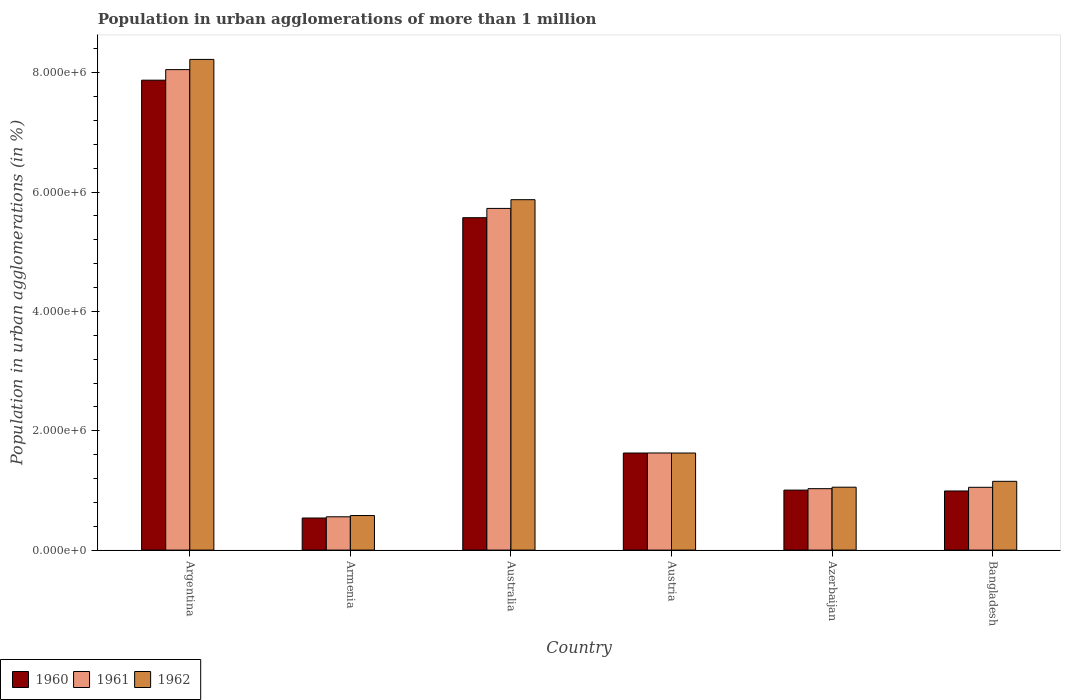How many bars are there on the 2nd tick from the left?
Your response must be concise. 3. In how many cases, is the number of bars for a given country not equal to the number of legend labels?
Make the answer very short. 0. What is the population in urban agglomerations in 1961 in Australia?
Your response must be concise. 5.73e+06. Across all countries, what is the maximum population in urban agglomerations in 1962?
Provide a short and direct response. 8.22e+06. Across all countries, what is the minimum population in urban agglomerations in 1960?
Offer a very short reply. 5.38e+05. In which country was the population in urban agglomerations in 1960 maximum?
Give a very brief answer. Argentina. In which country was the population in urban agglomerations in 1960 minimum?
Ensure brevity in your answer.  Armenia. What is the total population in urban agglomerations in 1962 in the graph?
Your answer should be very brief. 1.85e+07. What is the difference between the population in urban agglomerations in 1960 in Argentina and that in Azerbaijan?
Ensure brevity in your answer.  6.87e+06. What is the difference between the population in urban agglomerations in 1960 in Austria and the population in urban agglomerations in 1962 in Bangladesh?
Offer a very short reply. 4.74e+05. What is the average population in urban agglomerations in 1962 per country?
Keep it short and to the point. 3.08e+06. What is the difference between the population in urban agglomerations of/in 1960 and population in urban agglomerations of/in 1961 in Bangladesh?
Your answer should be very brief. -6.15e+04. In how many countries, is the population in urban agglomerations in 1962 greater than 6000000 %?
Offer a very short reply. 1. What is the ratio of the population in urban agglomerations in 1961 in Argentina to that in Austria?
Your answer should be compact. 4.95. Is the population in urban agglomerations in 1961 in Australia less than that in Austria?
Offer a terse response. No. Is the difference between the population in urban agglomerations in 1960 in Australia and Azerbaijan greater than the difference between the population in urban agglomerations in 1961 in Australia and Azerbaijan?
Keep it short and to the point. No. What is the difference between the highest and the second highest population in urban agglomerations in 1962?
Your response must be concise. -2.35e+06. What is the difference between the highest and the lowest population in urban agglomerations in 1960?
Keep it short and to the point. 7.34e+06. In how many countries, is the population in urban agglomerations in 1962 greater than the average population in urban agglomerations in 1962 taken over all countries?
Keep it short and to the point. 2. What does the 3rd bar from the left in Azerbaijan represents?
Provide a succinct answer. 1962. Is it the case that in every country, the sum of the population in urban agglomerations in 1960 and population in urban agglomerations in 1961 is greater than the population in urban agglomerations in 1962?
Make the answer very short. Yes. How many bars are there?
Offer a very short reply. 18. What is the difference between two consecutive major ticks on the Y-axis?
Ensure brevity in your answer.  2.00e+06. Where does the legend appear in the graph?
Offer a very short reply. Bottom left. How are the legend labels stacked?
Give a very brief answer. Horizontal. What is the title of the graph?
Your answer should be compact. Population in urban agglomerations of more than 1 million. Does "2015" appear as one of the legend labels in the graph?
Make the answer very short. No. What is the label or title of the Y-axis?
Offer a very short reply. Population in urban agglomerations (in %). What is the Population in urban agglomerations (in %) of 1960 in Argentina?
Your response must be concise. 7.87e+06. What is the Population in urban agglomerations (in %) of 1961 in Argentina?
Provide a succinct answer. 8.05e+06. What is the Population in urban agglomerations (in %) in 1962 in Argentina?
Your answer should be very brief. 8.22e+06. What is the Population in urban agglomerations (in %) of 1960 in Armenia?
Give a very brief answer. 5.38e+05. What is the Population in urban agglomerations (in %) in 1961 in Armenia?
Ensure brevity in your answer.  5.58e+05. What is the Population in urban agglomerations (in %) of 1962 in Armenia?
Give a very brief answer. 5.79e+05. What is the Population in urban agglomerations (in %) of 1960 in Australia?
Your answer should be compact. 5.57e+06. What is the Population in urban agglomerations (in %) of 1961 in Australia?
Keep it short and to the point. 5.73e+06. What is the Population in urban agglomerations (in %) of 1962 in Australia?
Provide a succinct answer. 5.87e+06. What is the Population in urban agglomerations (in %) of 1960 in Austria?
Provide a short and direct response. 1.63e+06. What is the Population in urban agglomerations (in %) of 1961 in Austria?
Make the answer very short. 1.63e+06. What is the Population in urban agglomerations (in %) of 1962 in Austria?
Your response must be concise. 1.63e+06. What is the Population in urban agglomerations (in %) of 1960 in Azerbaijan?
Ensure brevity in your answer.  1.01e+06. What is the Population in urban agglomerations (in %) in 1961 in Azerbaijan?
Provide a succinct answer. 1.03e+06. What is the Population in urban agglomerations (in %) of 1962 in Azerbaijan?
Your answer should be compact. 1.05e+06. What is the Population in urban agglomerations (in %) in 1960 in Bangladesh?
Offer a terse response. 9.91e+05. What is the Population in urban agglomerations (in %) of 1961 in Bangladesh?
Give a very brief answer. 1.05e+06. What is the Population in urban agglomerations (in %) of 1962 in Bangladesh?
Your answer should be compact. 1.15e+06. Across all countries, what is the maximum Population in urban agglomerations (in %) in 1960?
Provide a succinct answer. 7.87e+06. Across all countries, what is the maximum Population in urban agglomerations (in %) in 1961?
Provide a short and direct response. 8.05e+06. Across all countries, what is the maximum Population in urban agglomerations (in %) of 1962?
Provide a succinct answer. 8.22e+06. Across all countries, what is the minimum Population in urban agglomerations (in %) of 1960?
Provide a succinct answer. 5.38e+05. Across all countries, what is the minimum Population in urban agglomerations (in %) in 1961?
Your response must be concise. 5.58e+05. Across all countries, what is the minimum Population in urban agglomerations (in %) in 1962?
Provide a short and direct response. 5.79e+05. What is the total Population in urban agglomerations (in %) of 1960 in the graph?
Give a very brief answer. 1.76e+07. What is the total Population in urban agglomerations (in %) of 1961 in the graph?
Your answer should be very brief. 1.80e+07. What is the total Population in urban agglomerations (in %) of 1962 in the graph?
Your answer should be very brief. 1.85e+07. What is the difference between the Population in urban agglomerations (in %) in 1960 in Argentina and that in Armenia?
Provide a succinct answer. 7.34e+06. What is the difference between the Population in urban agglomerations (in %) in 1961 in Argentina and that in Armenia?
Provide a short and direct response. 7.49e+06. What is the difference between the Population in urban agglomerations (in %) in 1962 in Argentina and that in Armenia?
Provide a succinct answer. 7.64e+06. What is the difference between the Population in urban agglomerations (in %) in 1960 in Argentina and that in Australia?
Your answer should be compact. 2.30e+06. What is the difference between the Population in urban agglomerations (in %) of 1961 in Argentina and that in Australia?
Your response must be concise. 2.33e+06. What is the difference between the Population in urban agglomerations (in %) of 1962 in Argentina and that in Australia?
Your answer should be very brief. 2.35e+06. What is the difference between the Population in urban agglomerations (in %) of 1960 in Argentina and that in Austria?
Provide a short and direct response. 6.25e+06. What is the difference between the Population in urban agglomerations (in %) of 1961 in Argentina and that in Austria?
Keep it short and to the point. 6.42e+06. What is the difference between the Population in urban agglomerations (in %) of 1962 in Argentina and that in Austria?
Offer a very short reply. 6.60e+06. What is the difference between the Population in urban agglomerations (in %) of 1960 in Argentina and that in Azerbaijan?
Your answer should be compact. 6.87e+06. What is the difference between the Population in urban agglomerations (in %) in 1961 in Argentina and that in Azerbaijan?
Offer a very short reply. 7.02e+06. What is the difference between the Population in urban agglomerations (in %) of 1962 in Argentina and that in Azerbaijan?
Provide a succinct answer. 7.17e+06. What is the difference between the Population in urban agglomerations (in %) of 1960 in Argentina and that in Bangladesh?
Your answer should be very brief. 6.88e+06. What is the difference between the Population in urban agglomerations (in %) in 1961 in Argentina and that in Bangladesh?
Your response must be concise. 7.00e+06. What is the difference between the Population in urban agglomerations (in %) of 1962 in Argentina and that in Bangladesh?
Give a very brief answer. 7.07e+06. What is the difference between the Population in urban agglomerations (in %) of 1960 in Armenia and that in Australia?
Ensure brevity in your answer.  -5.03e+06. What is the difference between the Population in urban agglomerations (in %) in 1961 in Armenia and that in Australia?
Your answer should be very brief. -5.17e+06. What is the difference between the Population in urban agglomerations (in %) in 1962 in Armenia and that in Australia?
Keep it short and to the point. -5.29e+06. What is the difference between the Population in urban agglomerations (in %) in 1960 in Armenia and that in Austria?
Your response must be concise. -1.09e+06. What is the difference between the Population in urban agglomerations (in %) in 1961 in Armenia and that in Austria?
Keep it short and to the point. -1.07e+06. What is the difference between the Population in urban agglomerations (in %) in 1962 in Armenia and that in Austria?
Offer a terse response. -1.05e+06. What is the difference between the Population in urban agglomerations (in %) in 1960 in Armenia and that in Azerbaijan?
Offer a very short reply. -4.68e+05. What is the difference between the Population in urban agglomerations (in %) of 1961 in Armenia and that in Azerbaijan?
Ensure brevity in your answer.  -4.71e+05. What is the difference between the Population in urban agglomerations (in %) of 1962 in Armenia and that in Azerbaijan?
Provide a short and direct response. -4.75e+05. What is the difference between the Population in urban agglomerations (in %) in 1960 in Armenia and that in Bangladesh?
Provide a succinct answer. -4.53e+05. What is the difference between the Population in urban agglomerations (in %) in 1961 in Armenia and that in Bangladesh?
Offer a very short reply. -4.94e+05. What is the difference between the Population in urban agglomerations (in %) in 1962 in Armenia and that in Bangladesh?
Offer a very short reply. -5.73e+05. What is the difference between the Population in urban agglomerations (in %) of 1960 in Australia and that in Austria?
Offer a terse response. 3.94e+06. What is the difference between the Population in urban agglomerations (in %) of 1961 in Australia and that in Austria?
Offer a very short reply. 4.10e+06. What is the difference between the Population in urban agglomerations (in %) of 1962 in Australia and that in Austria?
Your answer should be very brief. 4.25e+06. What is the difference between the Population in urban agglomerations (in %) in 1960 in Australia and that in Azerbaijan?
Give a very brief answer. 4.56e+06. What is the difference between the Population in urban agglomerations (in %) of 1961 in Australia and that in Azerbaijan?
Make the answer very short. 4.70e+06. What is the difference between the Population in urban agglomerations (in %) in 1962 in Australia and that in Azerbaijan?
Give a very brief answer. 4.82e+06. What is the difference between the Population in urban agglomerations (in %) in 1960 in Australia and that in Bangladesh?
Your answer should be compact. 4.58e+06. What is the difference between the Population in urban agglomerations (in %) of 1961 in Australia and that in Bangladesh?
Make the answer very short. 4.67e+06. What is the difference between the Population in urban agglomerations (in %) of 1962 in Australia and that in Bangladesh?
Offer a very short reply. 4.72e+06. What is the difference between the Population in urban agglomerations (in %) in 1960 in Austria and that in Azerbaijan?
Make the answer very short. 6.21e+05. What is the difference between the Population in urban agglomerations (in %) in 1961 in Austria and that in Azerbaijan?
Offer a terse response. 5.98e+05. What is the difference between the Population in urban agglomerations (in %) of 1962 in Austria and that in Azerbaijan?
Offer a very short reply. 5.72e+05. What is the difference between the Population in urban agglomerations (in %) of 1960 in Austria and that in Bangladesh?
Keep it short and to the point. 6.36e+05. What is the difference between the Population in urban agglomerations (in %) of 1961 in Austria and that in Bangladesh?
Keep it short and to the point. 5.75e+05. What is the difference between the Population in urban agglomerations (in %) in 1962 in Austria and that in Bangladesh?
Make the answer very short. 4.74e+05. What is the difference between the Population in urban agglomerations (in %) of 1960 in Azerbaijan and that in Bangladesh?
Offer a terse response. 1.46e+04. What is the difference between the Population in urban agglomerations (in %) in 1961 in Azerbaijan and that in Bangladesh?
Provide a succinct answer. -2.27e+04. What is the difference between the Population in urban agglomerations (in %) of 1962 in Azerbaijan and that in Bangladesh?
Your answer should be very brief. -9.84e+04. What is the difference between the Population in urban agglomerations (in %) in 1960 in Argentina and the Population in urban agglomerations (in %) in 1961 in Armenia?
Provide a succinct answer. 7.32e+06. What is the difference between the Population in urban agglomerations (in %) in 1960 in Argentina and the Population in urban agglomerations (in %) in 1962 in Armenia?
Offer a very short reply. 7.30e+06. What is the difference between the Population in urban agglomerations (in %) in 1961 in Argentina and the Population in urban agglomerations (in %) in 1962 in Armenia?
Make the answer very short. 7.47e+06. What is the difference between the Population in urban agglomerations (in %) in 1960 in Argentina and the Population in urban agglomerations (in %) in 1961 in Australia?
Offer a terse response. 2.15e+06. What is the difference between the Population in urban agglomerations (in %) of 1960 in Argentina and the Population in urban agglomerations (in %) of 1962 in Australia?
Your answer should be compact. 2.00e+06. What is the difference between the Population in urban agglomerations (in %) of 1961 in Argentina and the Population in urban agglomerations (in %) of 1962 in Australia?
Your answer should be very brief. 2.18e+06. What is the difference between the Population in urban agglomerations (in %) in 1960 in Argentina and the Population in urban agglomerations (in %) in 1961 in Austria?
Make the answer very short. 6.25e+06. What is the difference between the Population in urban agglomerations (in %) of 1960 in Argentina and the Population in urban agglomerations (in %) of 1962 in Austria?
Your answer should be very brief. 6.25e+06. What is the difference between the Population in urban agglomerations (in %) of 1961 in Argentina and the Population in urban agglomerations (in %) of 1962 in Austria?
Give a very brief answer. 6.42e+06. What is the difference between the Population in urban agglomerations (in %) in 1960 in Argentina and the Population in urban agglomerations (in %) in 1961 in Azerbaijan?
Provide a short and direct response. 6.84e+06. What is the difference between the Population in urban agglomerations (in %) in 1960 in Argentina and the Population in urban agglomerations (in %) in 1962 in Azerbaijan?
Provide a short and direct response. 6.82e+06. What is the difference between the Population in urban agglomerations (in %) of 1961 in Argentina and the Population in urban agglomerations (in %) of 1962 in Azerbaijan?
Your answer should be compact. 7.00e+06. What is the difference between the Population in urban agglomerations (in %) of 1960 in Argentina and the Population in urban agglomerations (in %) of 1961 in Bangladesh?
Keep it short and to the point. 6.82e+06. What is the difference between the Population in urban agglomerations (in %) of 1960 in Argentina and the Population in urban agglomerations (in %) of 1962 in Bangladesh?
Give a very brief answer. 6.72e+06. What is the difference between the Population in urban agglomerations (in %) of 1961 in Argentina and the Population in urban agglomerations (in %) of 1962 in Bangladesh?
Provide a succinct answer. 6.90e+06. What is the difference between the Population in urban agglomerations (in %) in 1960 in Armenia and the Population in urban agglomerations (in %) in 1961 in Australia?
Ensure brevity in your answer.  -5.19e+06. What is the difference between the Population in urban agglomerations (in %) in 1960 in Armenia and the Population in urban agglomerations (in %) in 1962 in Australia?
Offer a terse response. -5.33e+06. What is the difference between the Population in urban agglomerations (in %) in 1961 in Armenia and the Population in urban agglomerations (in %) in 1962 in Australia?
Keep it short and to the point. -5.31e+06. What is the difference between the Population in urban agglomerations (in %) in 1960 in Armenia and the Population in urban agglomerations (in %) in 1961 in Austria?
Your answer should be very brief. -1.09e+06. What is the difference between the Population in urban agglomerations (in %) of 1960 in Armenia and the Population in urban agglomerations (in %) of 1962 in Austria?
Offer a very short reply. -1.09e+06. What is the difference between the Population in urban agglomerations (in %) of 1961 in Armenia and the Population in urban agglomerations (in %) of 1962 in Austria?
Offer a terse response. -1.07e+06. What is the difference between the Population in urban agglomerations (in %) of 1960 in Armenia and the Population in urban agglomerations (in %) of 1961 in Azerbaijan?
Provide a succinct answer. -4.92e+05. What is the difference between the Population in urban agglomerations (in %) in 1960 in Armenia and the Population in urban agglomerations (in %) in 1962 in Azerbaijan?
Your answer should be very brief. -5.16e+05. What is the difference between the Population in urban agglomerations (in %) in 1961 in Armenia and the Population in urban agglomerations (in %) in 1962 in Azerbaijan?
Provide a short and direct response. -4.96e+05. What is the difference between the Population in urban agglomerations (in %) in 1960 in Armenia and the Population in urban agglomerations (in %) in 1961 in Bangladesh?
Your response must be concise. -5.14e+05. What is the difference between the Population in urban agglomerations (in %) of 1960 in Armenia and the Population in urban agglomerations (in %) of 1962 in Bangladesh?
Provide a short and direct response. -6.15e+05. What is the difference between the Population in urban agglomerations (in %) of 1961 in Armenia and the Population in urban agglomerations (in %) of 1962 in Bangladesh?
Ensure brevity in your answer.  -5.94e+05. What is the difference between the Population in urban agglomerations (in %) of 1960 in Australia and the Population in urban agglomerations (in %) of 1961 in Austria?
Give a very brief answer. 3.94e+06. What is the difference between the Population in urban agglomerations (in %) in 1960 in Australia and the Population in urban agglomerations (in %) in 1962 in Austria?
Provide a succinct answer. 3.94e+06. What is the difference between the Population in urban agglomerations (in %) of 1961 in Australia and the Population in urban agglomerations (in %) of 1962 in Austria?
Give a very brief answer. 4.10e+06. What is the difference between the Population in urban agglomerations (in %) of 1960 in Australia and the Population in urban agglomerations (in %) of 1961 in Azerbaijan?
Provide a short and direct response. 4.54e+06. What is the difference between the Population in urban agglomerations (in %) of 1960 in Australia and the Population in urban agglomerations (in %) of 1962 in Azerbaijan?
Provide a short and direct response. 4.52e+06. What is the difference between the Population in urban agglomerations (in %) in 1961 in Australia and the Population in urban agglomerations (in %) in 1962 in Azerbaijan?
Offer a terse response. 4.67e+06. What is the difference between the Population in urban agglomerations (in %) in 1960 in Australia and the Population in urban agglomerations (in %) in 1961 in Bangladesh?
Give a very brief answer. 4.52e+06. What is the difference between the Population in urban agglomerations (in %) in 1960 in Australia and the Population in urban agglomerations (in %) in 1962 in Bangladesh?
Offer a very short reply. 4.42e+06. What is the difference between the Population in urban agglomerations (in %) of 1961 in Australia and the Population in urban agglomerations (in %) of 1962 in Bangladesh?
Your answer should be compact. 4.57e+06. What is the difference between the Population in urban agglomerations (in %) in 1960 in Austria and the Population in urban agglomerations (in %) in 1961 in Azerbaijan?
Provide a short and direct response. 5.97e+05. What is the difference between the Population in urban agglomerations (in %) of 1960 in Austria and the Population in urban agglomerations (in %) of 1962 in Azerbaijan?
Provide a short and direct response. 5.73e+05. What is the difference between the Population in urban agglomerations (in %) of 1961 in Austria and the Population in urban agglomerations (in %) of 1962 in Azerbaijan?
Provide a short and direct response. 5.73e+05. What is the difference between the Population in urban agglomerations (in %) of 1960 in Austria and the Population in urban agglomerations (in %) of 1961 in Bangladesh?
Your answer should be compact. 5.75e+05. What is the difference between the Population in urban agglomerations (in %) in 1960 in Austria and the Population in urban agglomerations (in %) in 1962 in Bangladesh?
Provide a succinct answer. 4.74e+05. What is the difference between the Population in urban agglomerations (in %) in 1961 in Austria and the Population in urban agglomerations (in %) in 1962 in Bangladesh?
Offer a terse response. 4.75e+05. What is the difference between the Population in urban agglomerations (in %) of 1960 in Azerbaijan and the Population in urban agglomerations (in %) of 1961 in Bangladesh?
Your response must be concise. -4.69e+04. What is the difference between the Population in urban agglomerations (in %) in 1960 in Azerbaijan and the Population in urban agglomerations (in %) in 1962 in Bangladesh?
Your answer should be compact. -1.47e+05. What is the difference between the Population in urban agglomerations (in %) in 1961 in Azerbaijan and the Population in urban agglomerations (in %) in 1962 in Bangladesh?
Your answer should be very brief. -1.23e+05. What is the average Population in urban agglomerations (in %) of 1960 per country?
Your response must be concise. 2.93e+06. What is the average Population in urban agglomerations (in %) in 1961 per country?
Make the answer very short. 3.01e+06. What is the average Population in urban agglomerations (in %) in 1962 per country?
Offer a terse response. 3.08e+06. What is the difference between the Population in urban agglomerations (in %) in 1960 and Population in urban agglomerations (in %) in 1961 in Argentina?
Ensure brevity in your answer.  -1.77e+05. What is the difference between the Population in urban agglomerations (in %) of 1960 and Population in urban agglomerations (in %) of 1962 in Argentina?
Ensure brevity in your answer.  -3.48e+05. What is the difference between the Population in urban agglomerations (in %) of 1961 and Population in urban agglomerations (in %) of 1962 in Argentina?
Your answer should be very brief. -1.71e+05. What is the difference between the Population in urban agglomerations (in %) of 1960 and Population in urban agglomerations (in %) of 1961 in Armenia?
Provide a succinct answer. -2.04e+04. What is the difference between the Population in urban agglomerations (in %) of 1960 and Population in urban agglomerations (in %) of 1962 in Armenia?
Provide a succinct answer. -4.15e+04. What is the difference between the Population in urban agglomerations (in %) of 1961 and Population in urban agglomerations (in %) of 1962 in Armenia?
Provide a succinct answer. -2.12e+04. What is the difference between the Population in urban agglomerations (in %) of 1960 and Population in urban agglomerations (in %) of 1961 in Australia?
Offer a terse response. -1.55e+05. What is the difference between the Population in urban agglomerations (in %) of 1960 and Population in urban agglomerations (in %) of 1962 in Australia?
Provide a short and direct response. -3.02e+05. What is the difference between the Population in urban agglomerations (in %) of 1961 and Population in urban agglomerations (in %) of 1962 in Australia?
Your answer should be compact. -1.46e+05. What is the difference between the Population in urban agglomerations (in %) of 1960 and Population in urban agglomerations (in %) of 1961 in Austria?
Your answer should be compact. -630. What is the difference between the Population in urban agglomerations (in %) of 1960 and Population in urban agglomerations (in %) of 1962 in Austria?
Your response must be concise. 129. What is the difference between the Population in urban agglomerations (in %) of 1961 and Population in urban agglomerations (in %) of 1962 in Austria?
Ensure brevity in your answer.  759. What is the difference between the Population in urban agglomerations (in %) in 1960 and Population in urban agglomerations (in %) in 1961 in Azerbaijan?
Keep it short and to the point. -2.41e+04. What is the difference between the Population in urban agglomerations (in %) in 1960 and Population in urban agglomerations (in %) in 1962 in Azerbaijan?
Your answer should be compact. -4.89e+04. What is the difference between the Population in urban agglomerations (in %) in 1961 and Population in urban agglomerations (in %) in 1962 in Azerbaijan?
Offer a terse response. -2.47e+04. What is the difference between the Population in urban agglomerations (in %) of 1960 and Population in urban agglomerations (in %) of 1961 in Bangladesh?
Your answer should be compact. -6.15e+04. What is the difference between the Population in urban agglomerations (in %) in 1960 and Population in urban agglomerations (in %) in 1962 in Bangladesh?
Make the answer very short. -1.62e+05. What is the difference between the Population in urban agglomerations (in %) of 1961 and Population in urban agglomerations (in %) of 1962 in Bangladesh?
Provide a short and direct response. -1.00e+05. What is the ratio of the Population in urban agglomerations (in %) of 1960 in Argentina to that in Armenia?
Give a very brief answer. 14.64. What is the ratio of the Population in urban agglomerations (in %) in 1961 in Argentina to that in Armenia?
Keep it short and to the point. 14.43. What is the ratio of the Population in urban agglomerations (in %) of 1962 in Argentina to that in Armenia?
Provide a short and direct response. 14.19. What is the ratio of the Population in urban agglomerations (in %) in 1960 in Argentina to that in Australia?
Your response must be concise. 1.41. What is the ratio of the Population in urban agglomerations (in %) in 1961 in Argentina to that in Australia?
Your response must be concise. 1.41. What is the ratio of the Population in urban agglomerations (in %) in 1962 in Argentina to that in Australia?
Provide a succinct answer. 1.4. What is the ratio of the Population in urban agglomerations (in %) of 1960 in Argentina to that in Austria?
Make the answer very short. 4.84. What is the ratio of the Population in urban agglomerations (in %) in 1961 in Argentina to that in Austria?
Provide a short and direct response. 4.95. What is the ratio of the Population in urban agglomerations (in %) of 1962 in Argentina to that in Austria?
Provide a short and direct response. 5.05. What is the ratio of the Population in urban agglomerations (in %) of 1960 in Argentina to that in Azerbaijan?
Your answer should be compact. 7.83. What is the ratio of the Population in urban agglomerations (in %) of 1961 in Argentina to that in Azerbaijan?
Your answer should be compact. 7.82. What is the ratio of the Population in urban agglomerations (in %) of 1962 in Argentina to that in Azerbaijan?
Provide a short and direct response. 7.8. What is the ratio of the Population in urban agglomerations (in %) in 1960 in Argentina to that in Bangladesh?
Offer a very short reply. 7.95. What is the ratio of the Population in urban agglomerations (in %) in 1961 in Argentina to that in Bangladesh?
Your response must be concise. 7.65. What is the ratio of the Population in urban agglomerations (in %) in 1962 in Argentina to that in Bangladesh?
Keep it short and to the point. 7.13. What is the ratio of the Population in urban agglomerations (in %) in 1960 in Armenia to that in Australia?
Keep it short and to the point. 0.1. What is the ratio of the Population in urban agglomerations (in %) of 1961 in Armenia to that in Australia?
Your answer should be compact. 0.1. What is the ratio of the Population in urban agglomerations (in %) in 1962 in Armenia to that in Australia?
Provide a short and direct response. 0.1. What is the ratio of the Population in urban agglomerations (in %) in 1960 in Armenia to that in Austria?
Make the answer very short. 0.33. What is the ratio of the Population in urban agglomerations (in %) of 1961 in Armenia to that in Austria?
Keep it short and to the point. 0.34. What is the ratio of the Population in urban agglomerations (in %) of 1962 in Armenia to that in Austria?
Give a very brief answer. 0.36. What is the ratio of the Population in urban agglomerations (in %) in 1960 in Armenia to that in Azerbaijan?
Make the answer very short. 0.53. What is the ratio of the Population in urban agglomerations (in %) in 1961 in Armenia to that in Azerbaijan?
Provide a short and direct response. 0.54. What is the ratio of the Population in urban agglomerations (in %) in 1962 in Armenia to that in Azerbaijan?
Keep it short and to the point. 0.55. What is the ratio of the Population in urban agglomerations (in %) of 1960 in Armenia to that in Bangladesh?
Offer a terse response. 0.54. What is the ratio of the Population in urban agglomerations (in %) in 1961 in Armenia to that in Bangladesh?
Provide a short and direct response. 0.53. What is the ratio of the Population in urban agglomerations (in %) of 1962 in Armenia to that in Bangladesh?
Provide a short and direct response. 0.5. What is the ratio of the Population in urban agglomerations (in %) of 1960 in Australia to that in Austria?
Make the answer very short. 3.42. What is the ratio of the Population in urban agglomerations (in %) in 1961 in Australia to that in Austria?
Give a very brief answer. 3.52. What is the ratio of the Population in urban agglomerations (in %) of 1962 in Australia to that in Austria?
Keep it short and to the point. 3.61. What is the ratio of the Population in urban agglomerations (in %) in 1960 in Australia to that in Azerbaijan?
Your answer should be very brief. 5.54. What is the ratio of the Population in urban agglomerations (in %) of 1961 in Australia to that in Azerbaijan?
Offer a very short reply. 5.56. What is the ratio of the Population in urban agglomerations (in %) of 1962 in Australia to that in Azerbaijan?
Provide a short and direct response. 5.57. What is the ratio of the Population in urban agglomerations (in %) of 1960 in Australia to that in Bangladesh?
Ensure brevity in your answer.  5.62. What is the ratio of the Population in urban agglomerations (in %) of 1961 in Australia to that in Bangladesh?
Give a very brief answer. 5.44. What is the ratio of the Population in urban agglomerations (in %) of 1962 in Australia to that in Bangladesh?
Provide a short and direct response. 5.09. What is the ratio of the Population in urban agglomerations (in %) in 1960 in Austria to that in Azerbaijan?
Provide a succinct answer. 1.62. What is the ratio of the Population in urban agglomerations (in %) in 1961 in Austria to that in Azerbaijan?
Provide a short and direct response. 1.58. What is the ratio of the Population in urban agglomerations (in %) in 1962 in Austria to that in Azerbaijan?
Ensure brevity in your answer.  1.54. What is the ratio of the Population in urban agglomerations (in %) in 1960 in Austria to that in Bangladesh?
Offer a terse response. 1.64. What is the ratio of the Population in urban agglomerations (in %) in 1961 in Austria to that in Bangladesh?
Make the answer very short. 1.55. What is the ratio of the Population in urban agglomerations (in %) of 1962 in Austria to that in Bangladesh?
Keep it short and to the point. 1.41. What is the ratio of the Population in urban agglomerations (in %) in 1960 in Azerbaijan to that in Bangladesh?
Offer a terse response. 1.01. What is the ratio of the Population in urban agglomerations (in %) of 1961 in Azerbaijan to that in Bangladesh?
Keep it short and to the point. 0.98. What is the ratio of the Population in urban agglomerations (in %) of 1962 in Azerbaijan to that in Bangladesh?
Ensure brevity in your answer.  0.91. What is the difference between the highest and the second highest Population in urban agglomerations (in %) of 1960?
Your answer should be compact. 2.30e+06. What is the difference between the highest and the second highest Population in urban agglomerations (in %) in 1961?
Provide a succinct answer. 2.33e+06. What is the difference between the highest and the second highest Population in urban agglomerations (in %) of 1962?
Provide a short and direct response. 2.35e+06. What is the difference between the highest and the lowest Population in urban agglomerations (in %) in 1960?
Offer a terse response. 7.34e+06. What is the difference between the highest and the lowest Population in urban agglomerations (in %) of 1961?
Ensure brevity in your answer.  7.49e+06. What is the difference between the highest and the lowest Population in urban agglomerations (in %) of 1962?
Your response must be concise. 7.64e+06. 